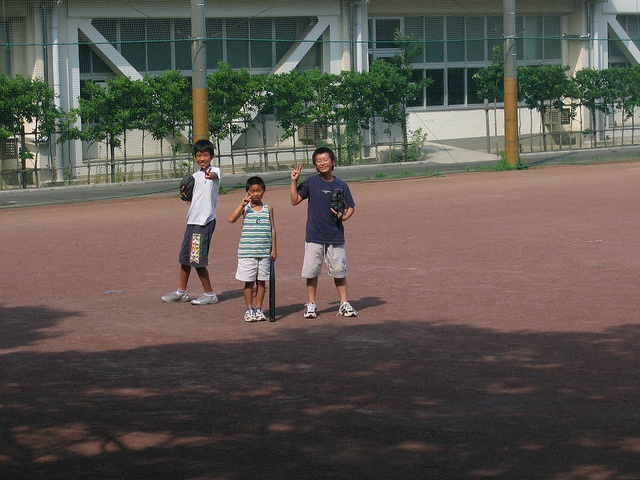Describe the objects in this image and their specific colors. I can see people in black, darkgray, and brown tones, people in black, gray, darkgray, and lightgray tones, people in black, lightgray, gray, and darkgray tones, baseball glove in black, gray, and maroon tones, and baseball bat in black and gray tones in this image. 